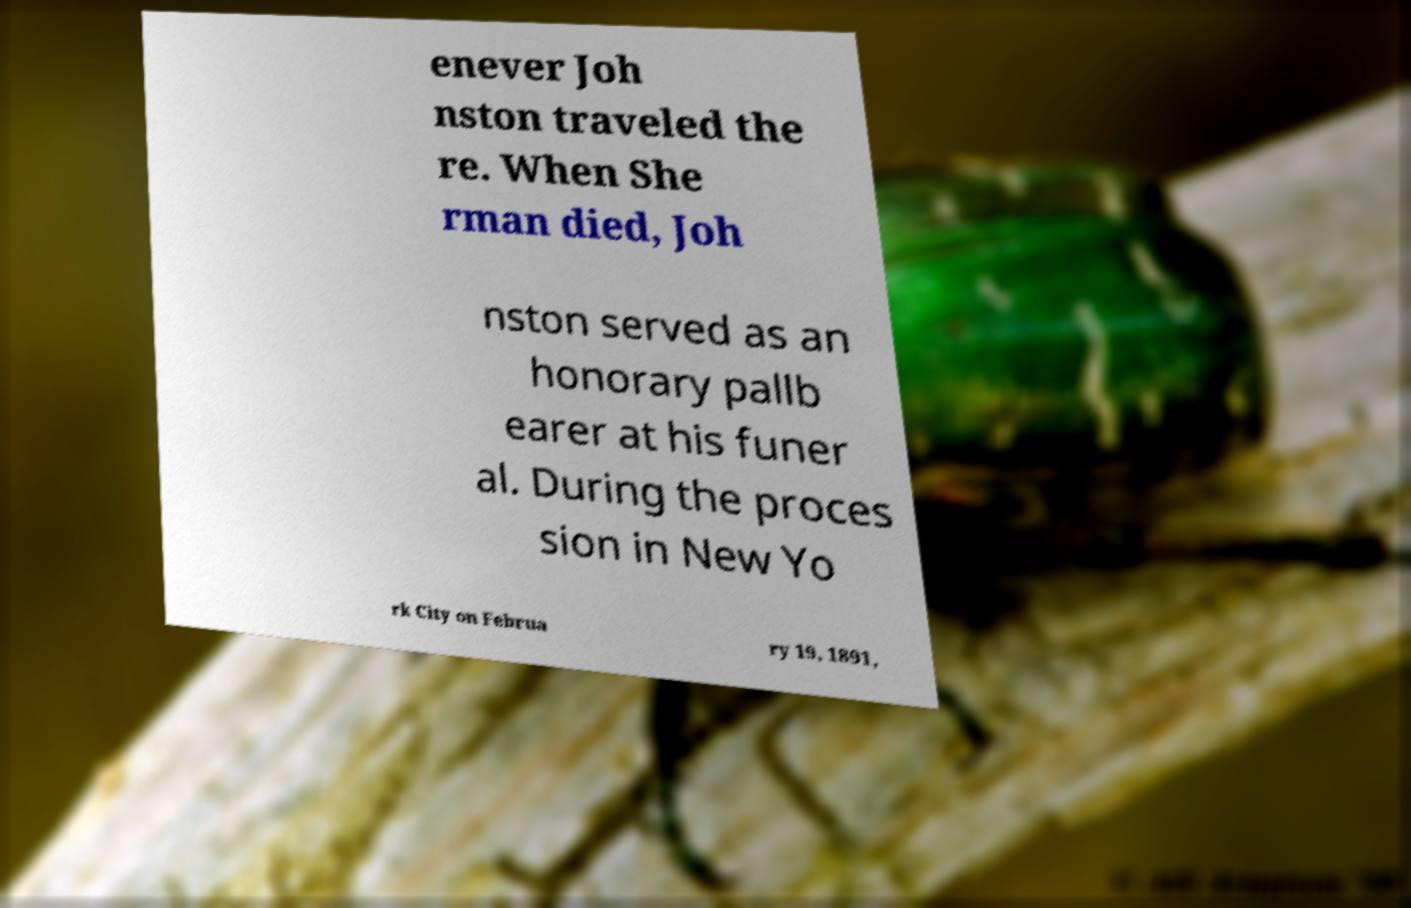Please identify and transcribe the text found in this image. enever Joh nston traveled the re. When She rman died, Joh nston served as an honorary pallb earer at his funer al. During the proces sion in New Yo rk City on Februa ry 19, 1891, 